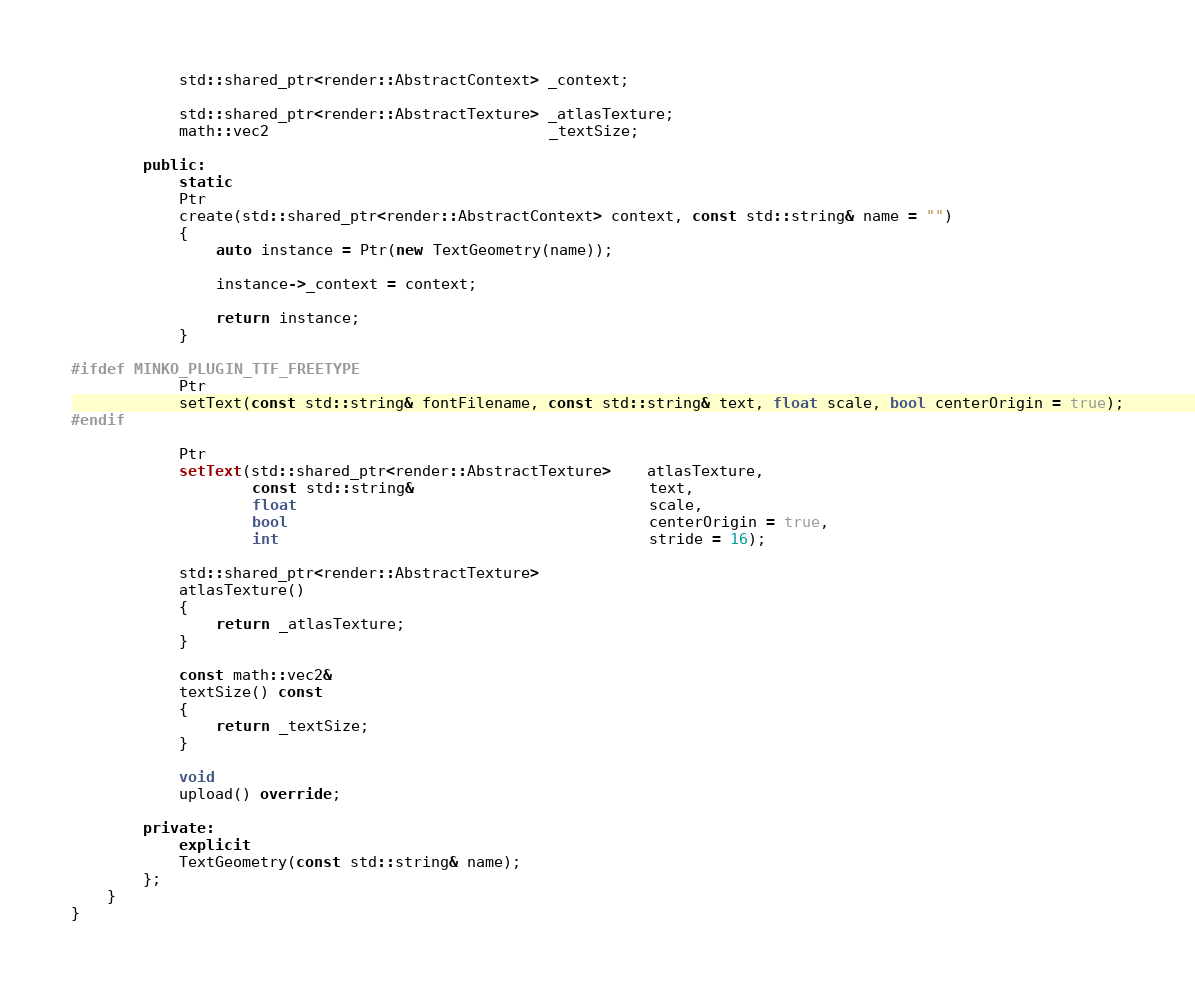<code> <loc_0><loc_0><loc_500><loc_500><_C++_>            std::shared_ptr<render::AbstractContext> _context;

            std::shared_ptr<render::AbstractTexture> _atlasTexture;
            math::vec2                               _textSize;

        public:
            static
            Ptr
            create(std::shared_ptr<render::AbstractContext> context, const std::string& name = "")
            {
                auto instance = Ptr(new TextGeometry(name));

                instance->_context = context;

                return instance;
            }

#ifdef MINKO_PLUGIN_TTF_FREETYPE
            Ptr
            setText(const std::string& fontFilename, const std::string& text, float scale, bool centerOrigin = true);
#endif

            Ptr
            setText(std::shared_ptr<render::AbstractTexture>    atlasTexture,
                    const std::string&                          text,
                    float                                       scale,
                    bool                                        centerOrigin = true,
                    int                                         stride = 16);

            std::shared_ptr<render::AbstractTexture>
            atlasTexture()
            {
                return _atlasTexture;
            }

            const math::vec2&
            textSize() const
            {
                return _textSize;
            }

            void
            upload() override;

        private:
            explicit
            TextGeometry(const std::string& name);
        };
    }
}
</code> 